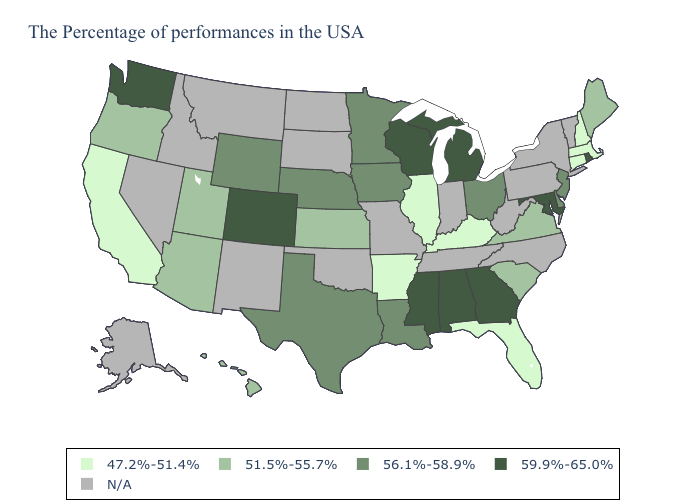Name the states that have a value in the range N/A?
Write a very short answer. Vermont, New York, Pennsylvania, North Carolina, West Virginia, Indiana, Tennessee, Missouri, Oklahoma, South Dakota, North Dakota, New Mexico, Montana, Idaho, Nevada, Alaska. What is the value of Missouri?
Concise answer only. N/A. Among the states that border Colorado , which have the highest value?
Give a very brief answer. Nebraska, Wyoming. What is the highest value in the USA?
Concise answer only. 59.9%-65.0%. What is the lowest value in the South?
Quick response, please. 47.2%-51.4%. What is the lowest value in the West?
Short answer required. 47.2%-51.4%. What is the value of Alaska?
Give a very brief answer. N/A. Among the states that border North Carolina , which have the highest value?
Keep it brief. Georgia. What is the value of Delaware?
Give a very brief answer. 56.1%-58.9%. What is the value of New York?
Answer briefly. N/A. Which states have the highest value in the USA?
Answer briefly. Rhode Island, Maryland, Georgia, Michigan, Alabama, Wisconsin, Mississippi, Colorado, Washington. Name the states that have a value in the range 56.1%-58.9%?
Quick response, please. New Jersey, Delaware, Ohio, Louisiana, Minnesota, Iowa, Nebraska, Texas, Wyoming. What is the value of West Virginia?
Be succinct. N/A. Name the states that have a value in the range 56.1%-58.9%?
Quick response, please. New Jersey, Delaware, Ohio, Louisiana, Minnesota, Iowa, Nebraska, Texas, Wyoming. What is the value of Vermont?
Concise answer only. N/A. 